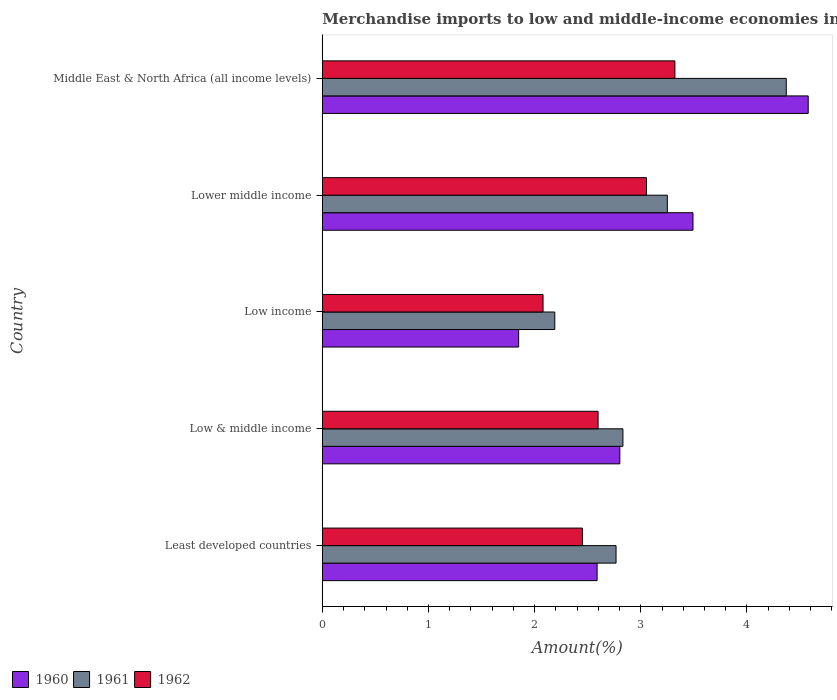How many different coloured bars are there?
Keep it short and to the point. 3. Are the number of bars per tick equal to the number of legend labels?
Provide a short and direct response. Yes. Are the number of bars on each tick of the Y-axis equal?
Make the answer very short. Yes. What is the label of the 3rd group of bars from the top?
Your answer should be compact. Low income. In how many cases, is the number of bars for a given country not equal to the number of legend labels?
Your answer should be compact. 0. What is the percentage of amount earned from merchandise imports in 1961 in Middle East & North Africa (all income levels)?
Provide a short and direct response. 4.37. Across all countries, what is the maximum percentage of amount earned from merchandise imports in 1960?
Provide a succinct answer. 4.58. Across all countries, what is the minimum percentage of amount earned from merchandise imports in 1961?
Your response must be concise. 2.19. In which country was the percentage of amount earned from merchandise imports in 1962 maximum?
Keep it short and to the point. Middle East & North Africa (all income levels). What is the total percentage of amount earned from merchandise imports in 1962 in the graph?
Keep it short and to the point. 13.5. What is the difference between the percentage of amount earned from merchandise imports in 1962 in Low & middle income and that in Lower middle income?
Give a very brief answer. -0.46. What is the difference between the percentage of amount earned from merchandise imports in 1962 in Lower middle income and the percentage of amount earned from merchandise imports in 1960 in Low & middle income?
Provide a short and direct response. 0.25. What is the average percentage of amount earned from merchandise imports in 1960 per country?
Your response must be concise. 3.06. What is the difference between the percentage of amount earned from merchandise imports in 1962 and percentage of amount earned from merchandise imports in 1961 in Least developed countries?
Ensure brevity in your answer.  -0.32. In how many countries, is the percentage of amount earned from merchandise imports in 1960 greater than 3.8 %?
Your answer should be very brief. 1. What is the ratio of the percentage of amount earned from merchandise imports in 1960 in Least developed countries to that in Low income?
Your answer should be compact. 1.4. Is the difference between the percentage of amount earned from merchandise imports in 1962 in Low & middle income and Low income greater than the difference between the percentage of amount earned from merchandise imports in 1961 in Low & middle income and Low income?
Your response must be concise. No. What is the difference between the highest and the second highest percentage of amount earned from merchandise imports in 1962?
Provide a short and direct response. 0.27. What is the difference between the highest and the lowest percentage of amount earned from merchandise imports in 1960?
Offer a terse response. 2.73. Is the sum of the percentage of amount earned from merchandise imports in 1960 in Least developed countries and Middle East & North Africa (all income levels) greater than the maximum percentage of amount earned from merchandise imports in 1962 across all countries?
Provide a short and direct response. Yes. What does the 1st bar from the bottom in Middle East & North Africa (all income levels) represents?
Offer a very short reply. 1960. Is it the case that in every country, the sum of the percentage of amount earned from merchandise imports in 1960 and percentage of amount earned from merchandise imports in 1962 is greater than the percentage of amount earned from merchandise imports in 1961?
Offer a very short reply. Yes. What is the difference between two consecutive major ticks on the X-axis?
Provide a succinct answer. 1. Does the graph contain any zero values?
Give a very brief answer. No. Does the graph contain grids?
Make the answer very short. No. Where does the legend appear in the graph?
Keep it short and to the point. Bottom left. What is the title of the graph?
Make the answer very short. Merchandise imports to low and middle-income economies in the Arab World. What is the label or title of the X-axis?
Make the answer very short. Amount(%). What is the label or title of the Y-axis?
Make the answer very short. Country. What is the Amount(%) in 1960 in Least developed countries?
Your answer should be very brief. 2.59. What is the Amount(%) in 1961 in Least developed countries?
Offer a terse response. 2.77. What is the Amount(%) in 1962 in Least developed countries?
Your response must be concise. 2.45. What is the Amount(%) of 1960 in Low & middle income?
Give a very brief answer. 2.8. What is the Amount(%) of 1961 in Low & middle income?
Ensure brevity in your answer.  2.83. What is the Amount(%) of 1962 in Low & middle income?
Offer a terse response. 2.6. What is the Amount(%) in 1960 in Low income?
Provide a succinct answer. 1.85. What is the Amount(%) of 1961 in Low income?
Your response must be concise. 2.19. What is the Amount(%) of 1962 in Low income?
Ensure brevity in your answer.  2.08. What is the Amount(%) of 1960 in Lower middle income?
Ensure brevity in your answer.  3.49. What is the Amount(%) in 1961 in Lower middle income?
Provide a succinct answer. 3.25. What is the Amount(%) in 1962 in Lower middle income?
Give a very brief answer. 3.05. What is the Amount(%) of 1960 in Middle East & North Africa (all income levels)?
Provide a short and direct response. 4.58. What is the Amount(%) in 1961 in Middle East & North Africa (all income levels)?
Offer a terse response. 4.37. What is the Amount(%) in 1962 in Middle East & North Africa (all income levels)?
Give a very brief answer. 3.32. Across all countries, what is the maximum Amount(%) of 1960?
Your answer should be very brief. 4.58. Across all countries, what is the maximum Amount(%) of 1961?
Offer a terse response. 4.37. Across all countries, what is the maximum Amount(%) of 1962?
Your answer should be very brief. 3.32. Across all countries, what is the minimum Amount(%) of 1960?
Your answer should be compact. 1.85. Across all countries, what is the minimum Amount(%) in 1961?
Your response must be concise. 2.19. Across all countries, what is the minimum Amount(%) of 1962?
Your answer should be very brief. 2.08. What is the total Amount(%) of 1960 in the graph?
Your answer should be compact. 15.31. What is the total Amount(%) in 1961 in the graph?
Make the answer very short. 15.41. What is the total Amount(%) of 1962 in the graph?
Keep it short and to the point. 13.5. What is the difference between the Amount(%) in 1960 in Least developed countries and that in Low & middle income?
Your answer should be very brief. -0.21. What is the difference between the Amount(%) of 1961 in Least developed countries and that in Low & middle income?
Your answer should be very brief. -0.06. What is the difference between the Amount(%) of 1962 in Least developed countries and that in Low & middle income?
Offer a very short reply. -0.15. What is the difference between the Amount(%) of 1960 in Least developed countries and that in Low income?
Provide a succinct answer. 0.74. What is the difference between the Amount(%) of 1961 in Least developed countries and that in Low income?
Ensure brevity in your answer.  0.58. What is the difference between the Amount(%) in 1962 in Least developed countries and that in Low income?
Keep it short and to the point. 0.37. What is the difference between the Amount(%) in 1960 in Least developed countries and that in Lower middle income?
Keep it short and to the point. -0.9. What is the difference between the Amount(%) in 1961 in Least developed countries and that in Lower middle income?
Offer a terse response. -0.48. What is the difference between the Amount(%) of 1962 in Least developed countries and that in Lower middle income?
Your answer should be very brief. -0.6. What is the difference between the Amount(%) in 1960 in Least developed countries and that in Middle East & North Africa (all income levels)?
Make the answer very short. -1.99. What is the difference between the Amount(%) of 1961 in Least developed countries and that in Middle East & North Africa (all income levels)?
Keep it short and to the point. -1.6. What is the difference between the Amount(%) of 1962 in Least developed countries and that in Middle East & North Africa (all income levels)?
Your answer should be compact. -0.87. What is the difference between the Amount(%) of 1960 in Low & middle income and that in Low income?
Your answer should be compact. 0.95. What is the difference between the Amount(%) of 1961 in Low & middle income and that in Low income?
Offer a terse response. 0.64. What is the difference between the Amount(%) in 1962 in Low & middle income and that in Low income?
Make the answer very short. 0.52. What is the difference between the Amount(%) in 1960 in Low & middle income and that in Lower middle income?
Give a very brief answer. -0.69. What is the difference between the Amount(%) in 1961 in Low & middle income and that in Lower middle income?
Keep it short and to the point. -0.42. What is the difference between the Amount(%) of 1962 in Low & middle income and that in Lower middle income?
Offer a terse response. -0.46. What is the difference between the Amount(%) in 1960 in Low & middle income and that in Middle East & North Africa (all income levels)?
Provide a short and direct response. -1.77. What is the difference between the Amount(%) of 1961 in Low & middle income and that in Middle East & North Africa (all income levels)?
Your answer should be very brief. -1.54. What is the difference between the Amount(%) of 1962 in Low & middle income and that in Middle East & North Africa (all income levels)?
Offer a very short reply. -0.72. What is the difference between the Amount(%) in 1960 in Low income and that in Lower middle income?
Your answer should be very brief. -1.64. What is the difference between the Amount(%) in 1961 in Low income and that in Lower middle income?
Give a very brief answer. -1.06. What is the difference between the Amount(%) in 1962 in Low income and that in Lower middle income?
Offer a terse response. -0.97. What is the difference between the Amount(%) in 1960 in Low income and that in Middle East & North Africa (all income levels)?
Give a very brief answer. -2.73. What is the difference between the Amount(%) in 1961 in Low income and that in Middle East & North Africa (all income levels)?
Your answer should be very brief. -2.18. What is the difference between the Amount(%) of 1962 in Low income and that in Middle East & North Africa (all income levels)?
Provide a succinct answer. -1.24. What is the difference between the Amount(%) of 1960 in Lower middle income and that in Middle East & North Africa (all income levels)?
Make the answer very short. -1.09. What is the difference between the Amount(%) of 1961 in Lower middle income and that in Middle East & North Africa (all income levels)?
Your answer should be very brief. -1.12. What is the difference between the Amount(%) of 1962 in Lower middle income and that in Middle East & North Africa (all income levels)?
Your answer should be compact. -0.27. What is the difference between the Amount(%) in 1960 in Least developed countries and the Amount(%) in 1961 in Low & middle income?
Give a very brief answer. -0.24. What is the difference between the Amount(%) in 1960 in Least developed countries and the Amount(%) in 1962 in Low & middle income?
Your answer should be very brief. -0.01. What is the difference between the Amount(%) of 1961 in Least developed countries and the Amount(%) of 1962 in Low & middle income?
Your answer should be very brief. 0.17. What is the difference between the Amount(%) of 1960 in Least developed countries and the Amount(%) of 1961 in Low income?
Make the answer very short. 0.4. What is the difference between the Amount(%) of 1960 in Least developed countries and the Amount(%) of 1962 in Low income?
Keep it short and to the point. 0.51. What is the difference between the Amount(%) in 1961 in Least developed countries and the Amount(%) in 1962 in Low income?
Provide a short and direct response. 0.69. What is the difference between the Amount(%) in 1960 in Least developed countries and the Amount(%) in 1961 in Lower middle income?
Provide a short and direct response. -0.66. What is the difference between the Amount(%) in 1960 in Least developed countries and the Amount(%) in 1962 in Lower middle income?
Your response must be concise. -0.47. What is the difference between the Amount(%) in 1961 in Least developed countries and the Amount(%) in 1962 in Lower middle income?
Give a very brief answer. -0.29. What is the difference between the Amount(%) in 1960 in Least developed countries and the Amount(%) in 1961 in Middle East & North Africa (all income levels)?
Offer a very short reply. -1.78. What is the difference between the Amount(%) of 1960 in Least developed countries and the Amount(%) of 1962 in Middle East & North Africa (all income levels)?
Offer a terse response. -0.73. What is the difference between the Amount(%) in 1961 in Least developed countries and the Amount(%) in 1962 in Middle East & North Africa (all income levels)?
Your response must be concise. -0.55. What is the difference between the Amount(%) of 1960 in Low & middle income and the Amount(%) of 1961 in Low income?
Keep it short and to the point. 0.61. What is the difference between the Amount(%) in 1960 in Low & middle income and the Amount(%) in 1962 in Low income?
Offer a terse response. 0.72. What is the difference between the Amount(%) in 1961 in Low & middle income and the Amount(%) in 1962 in Low income?
Provide a short and direct response. 0.75. What is the difference between the Amount(%) in 1960 in Low & middle income and the Amount(%) in 1961 in Lower middle income?
Your answer should be compact. -0.45. What is the difference between the Amount(%) of 1960 in Low & middle income and the Amount(%) of 1962 in Lower middle income?
Keep it short and to the point. -0.25. What is the difference between the Amount(%) in 1961 in Low & middle income and the Amount(%) in 1962 in Lower middle income?
Keep it short and to the point. -0.22. What is the difference between the Amount(%) of 1960 in Low & middle income and the Amount(%) of 1961 in Middle East & North Africa (all income levels)?
Your answer should be compact. -1.57. What is the difference between the Amount(%) of 1960 in Low & middle income and the Amount(%) of 1962 in Middle East & North Africa (all income levels)?
Ensure brevity in your answer.  -0.52. What is the difference between the Amount(%) of 1961 in Low & middle income and the Amount(%) of 1962 in Middle East & North Africa (all income levels)?
Keep it short and to the point. -0.49. What is the difference between the Amount(%) of 1960 in Low income and the Amount(%) of 1961 in Lower middle income?
Provide a succinct answer. -1.4. What is the difference between the Amount(%) in 1960 in Low income and the Amount(%) in 1962 in Lower middle income?
Your answer should be very brief. -1.2. What is the difference between the Amount(%) in 1961 in Low income and the Amount(%) in 1962 in Lower middle income?
Keep it short and to the point. -0.86. What is the difference between the Amount(%) in 1960 in Low income and the Amount(%) in 1961 in Middle East & North Africa (all income levels)?
Give a very brief answer. -2.52. What is the difference between the Amount(%) in 1960 in Low income and the Amount(%) in 1962 in Middle East & North Africa (all income levels)?
Offer a very short reply. -1.47. What is the difference between the Amount(%) of 1961 in Low income and the Amount(%) of 1962 in Middle East & North Africa (all income levels)?
Keep it short and to the point. -1.13. What is the difference between the Amount(%) of 1960 in Lower middle income and the Amount(%) of 1961 in Middle East & North Africa (all income levels)?
Keep it short and to the point. -0.88. What is the difference between the Amount(%) of 1960 in Lower middle income and the Amount(%) of 1962 in Middle East & North Africa (all income levels)?
Offer a very short reply. 0.17. What is the difference between the Amount(%) of 1961 in Lower middle income and the Amount(%) of 1962 in Middle East & North Africa (all income levels)?
Your answer should be compact. -0.07. What is the average Amount(%) of 1960 per country?
Ensure brevity in your answer.  3.06. What is the average Amount(%) in 1961 per country?
Keep it short and to the point. 3.08. What is the average Amount(%) in 1962 per country?
Offer a very short reply. 2.7. What is the difference between the Amount(%) of 1960 and Amount(%) of 1961 in Least developed countries?
Provide a short and direct response. -0.18. What is the difference between the Amount(%) in 1960 and Amount(%) in 1962 in Least developed countries?
Offer a terse response. 0.14. What is the difference between the Amount(%) in 1961 and Amount(%) in 1962 in Least developed countries?
Ensure brevity in your answer.  0.32. What is the difference between the Amount(%) of 1960 and Amount(%) of 1961 in Low & middle income?
Make the answer very short. -0.03. What is the difference between the Amount(%) of 1960 and Amount(%) of 1962 in Low & middle income?
Your answer should be compact. 0.2. What is the difference between the Amount(%) of 1961 and Amount(%) of 1962 in Low & middle income?
Your answer should be very brief. 0.23. What is the difference between the Amount(%) of 1960 and Amount(%) of 1961 in Low income?
Give a very brief answer. -0.34. What is the difference between the Amount(%) of 1960 and Amount(%) of 1962 in Low income?
Offer a very short reply. -0.23. What is the difference between the Amount(%) in 1961 and Amount(%) in 1962 in Low income?
Provide a succinct answer. 0.11. What is the difference between the Amount(%) in 1960 and Amount(%) in 1961 in Lower middle income?
Offer a terse response. 0.24. What is the difference between the Amount(%) of 1960 and Amount(%) of 1962 in Lower middle income?
Your answer should be compact. 0.44. What is the difference between the Amount(%) of 1961 and Amount(%) of 1962 in Lower middle income?
Keep it short and to the point. 0.2. What is the difference between the Amount(%) in 1960 and Amount(%) in 1961 in Middle East & North Africa (all income levels)?
Provide a succinct answer. 0.21. What is the difference between the Amount(%) in 1960 and Amount(%) in 1962 in Middle East & North Africa (all income levels)?
Offer a very short reply. 1.26. What is the difference between the Amount(%) in 1961 and Amount(%) in 1962 in Middle East & North Africa (all income levels)?
Keep it short and to the point. 1.05. What is the ratio of the Amount(%) of 1960 in Least developed countries to that in Low & middle income?
Your answer should be very brief. 0.92. What is the ratio of the Amount(%) of 1961 in Least developed countries to that in Low & middle income?
Offer a terse response. 0.98. What is the ratio of the Amount(%) in 1962 in Least developed countries to that in Low & middle income?
Provide a succinct answer. 0.94. What is the ratio of the Amount(%) of 1960 in Least developed countries to that in Low income?
Ensure brevity in your answer.  1.4. What is the ratio of the Amount(%) of 1961 in Least developed countries to that in Low income?
Keep it short and to the point. 1.26. What is the ratio of the Amount(%) in 1962 in Least developed countries to that in Low income?
Keep it short and to the point. 1.18. What is the ratio of the Amount(%) of 1960 in Least developed countries to that in Lower middle income?
Keep it short and to the point. 0.74. What is the ratio of the Amount(%) in 1961 in Least developed countries to that in Lower middle income?
Your answer should be compact. 0.85. What is the ratio of the Amount(%) of 1962 in Least developed countries to that in Lower middle income?
Your response must be concise. 0.8. What is the ratio of the Amount(%) of 1960 in Least developed countries to that in Middle East & North Africa (all income levels)?
Offer a terse response. 0.57. What is the ratio of the Amount(%) of 1961 in Least developed countries to that in Middle East & North Africa (all income levels)?
Ensure brevity in your answer.  0.63. What is the ratio of the Amount(%) of 1962 in Least developed countries to that in Middle East & North Africa (all income levels)?
Offer a terse response. 0.74. What is the ratio of the Amount(%) in 1960 in Low & middle income to that in Low income?
Keep it short and to the point. 1.52. What is the ratio of the Amount(%) in 1961 in Low & middle income to that in Low income?
Provide a short and direct response. 1.29. What is the ratio of the Amount(%) of 1962 in Low & middle income to that in Low income?
Provide a succinct answer. 1.25. What is the ratio of the Amount(%) in 1960 in Low & middle income to that in Lower middle income?
Offer a terse response. 0.8. What is the ratio of the Amount(%) in 1961 in Low & middle income to that in Lower middle income?
Give a very brief answer. 0.87. What is the ratio of the Amount(%) of 1962 in Low & middle income to that in Lower middle income?
Keep it short and to the point. 0.85. What is the ratio of the Amount(%) in 1960 in Low & middle income to that in Middle East & North Africa (all income levels)?
Your response must be concise. 0.61. What is the ratio of the Amount(%) of 1961 in Low & middle income to that in Middle East & North Africa (all income levels)?
Make the answer very short. 0.65. What is the ratio of the Amount(%) of 1962 in Low & middle income to that in Middle East & North Africa (all income levels)?
Your answer should be very brief. 0.78. What is the ratio of the Amount(%) in 1960 in Low income to that in Lower middle income?
Your response must be concise. 0.53. What is the ratio of the Amount(%) of 1961 in Low income to that in Lower middle income?
Offer a very short reply. 0.67. What is the ratio of the Amount(%) of 1962 in Low income to that in Lower middle income?
Give a very brief answer. 0.68. What is the ratio of the Amount(%) in 1960 in Low income to that in Middle East & North Africa (all income levels)?
Keep it short and to the point. 0.4. What is the ratio of the Amount(%) of 1961 in Low income to that in Middle East & North Africa (all income levels)?
Offer a very short reply. 0.5. What is the ratio of the Amount(%) of 1962 in Low income to that in Middle East & North Africa (all income levels)?
Ensure brevity in your answer.  0.63. What is the ratio of the Amount(%) of 1960 in Lower middle income to that in Middle East & North Africa (all income levels)?
Keep it short and to the point. 0.76. What is the ratio of the Amount(%) of 1961 in Lower middle income to that in Middle East & North Africa (all income levels)?
Offer a terse response. 0.74. What is the ratio of the Amount(%) of 1962 in Lower middle income to that in Middle East & North Africa (all income levels)?
Provide a succinct answer. 0.92. What is the difference between the highest and the second highest Amount(%) of 1960?
Offer a terse response. 1.09. What is the difference between the highest and the second highest Amount(%) of 1961?
Provide a succinct answer. 1.12. What is the difference between the highest and the second highest Amount(%) in 1962?
Provide a short and direct response. 0.27. What is the difference between the highest and the lowest Amount(%) in 1960?
Your response must be concise. 2.73. What is the difference between the highest and the lowest Amount(%) of 1961?
Offer a terse response. 2.18. What is the difference between the highest and the lowest Amount(%) in 1962?
Your answer should be very brief. 1.24. 